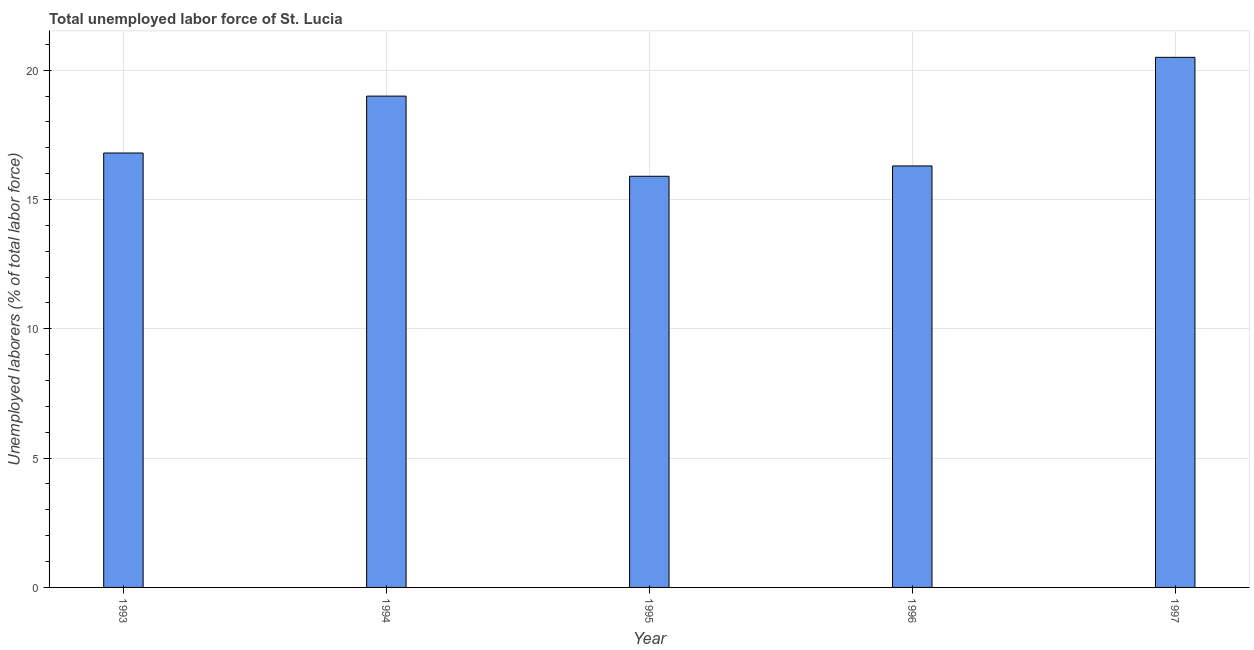Does the graph contain any zero values?
Your answer should be compact. No. Does the graph contain grids?
Give a very brief answer. Yes. What is the title of the graph?
Offer a terse response. Total unemployed labor force of St. Lucia. What is the label or title of the X-axis?
Keep it short and to the point. Year. What is the label or title of the Y-axis?
Make the answer very short. Unemployed laborers (% of total labor force). What is the total unemployed labour force in 1995?
Give a very brief answer. 15.9. Across all years, what is the maximum total unemployed labour force?
Your response must be concise. 20.5. Across all years, what is the minimum total unemployed labour force?
Keep it short and to the point. 15.9. In which year was the total unemployed labour force maximum?
Make the answer very short. 1997. In which year was the total unemployed labour force minimum?
Make the answer very short. 1995. What is the sum of the total unemployed labour force?
Give a very brief answer. 88.5. What is the median total unemployed labour force?
Offer a terse response. 16.8. What is the ratio of the total unemployed labour force in 1994 to that in 1996?
Your answer should be very brief. 1.17. Is the total unemployed labour force in 1995 less than that in 1996?
Make the answer very short. Yes. Is the difference between the total unemployed labour force in 1995 and 1997 greater than the difference between any two years?
Offer a very short reply. Yes. Is the sum of the total unemployed labour force in 1993 and 1997 greater than the maximum total unemployed labour force across all years?
Provide a succinct answer. Yes. How many bars are there?
Provide a short and direct response. 5. How many years are there in the graph?
Ensure brevity in your answer.  5. What is the difference between two consecutive major ticks on the Y-axis?
Keep it short and to the point. 5. Are the values on the major ticks of Y-axis written in scientific E-notation?
Offer a terse response. No. What is the Unemployed laborers (% of total labor force) in 1993?
Give a very brief answer. 16.8. What is the Unemployed laborers (% of total labor force) in 1995?
Your answer should be very brief. 15.9. What is the Unemployed laborers (% of total labor force) of 1996?
Your response must be concise. 16.3. What is the difference between the Unemployed laborers (% of total labor force) in 1993 and 1994?
Offer a terse response. -2.2. What is the difference between the Unemployed laborers (% of total labor force) in 1993 and 1995?
Ensure brevity in your answer.  0.9. What is the difference between the Unemployed laborers (% of total labor force) in 1993 and 1996?
Ensure brevity in your answer.  0.5. What is the difference between the Unemployed laborers (% of total labor force) in 1994 and 1996?
Provide a succinct answer. 2.7. What is the difference between the Unemployed laborers (% of total labor force) in 1995 and 1996?
Offer a terse response. -0.4. What is the ratio of the Unemployed laborers (% of total labor force) in 1993 to that in 1994?
Give a very brief answer. 0.88. What is the ratio of the Unemployed laborers (% of total labor force) in 1993 to that in 1995?
Provide a short and direct response. 1.06. What is the ratio of the Unemployed laborers (% of total labor force) in 1993 to that in 1996?
Provide a succinct answer. 1.03. What is the ratio of the Unemployed laborers (% of total labor force) in 1993 to that in 1997?
Provide a succinct answer. 0.82. What is the ratio of the Unemployed laborers (% of total labor force) in 1994 to that in 1995?
Give a very brief answer. 1.2. What is the ratio of the Unemployed laborers (% of total labor force) in 1994 to that in 1996?
Offer a very short reply. 1.17. What is the ratio of the Unemployed laborers (% of total labor force) in 1994 to that in 1997?
Make the answer very short. 0.93. What is the ratio of the Unemployed laborers (% of total labor force) in 1995 to that in 1997?
Offer a terse response. 0.78. What is the ratio of the Unemployed laborers (% of total labor force) in 1996 to that in 1997?
Your answer should be very brief. 0.8. 